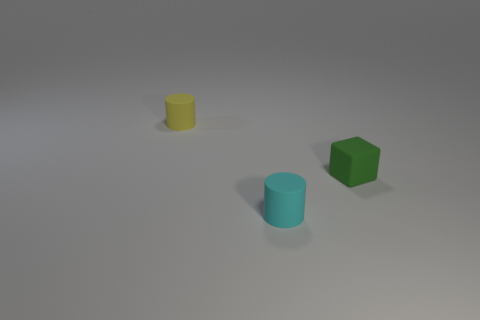Add 2 tiny green matte spheres. How many objects exist? 5 Subtract all cylinders. How many objects are left? 1 Subtract all rubber cylinders. Subtract all small cyan shiny cylinders. How many objects are left? 1 Add 2 cylinders. How many cylinders are left? 4 Add 3 large blue rubber cubes. How many large blue rubber cubes exist? 3 Subtract 0 green spheres. How many objects are left? 3 